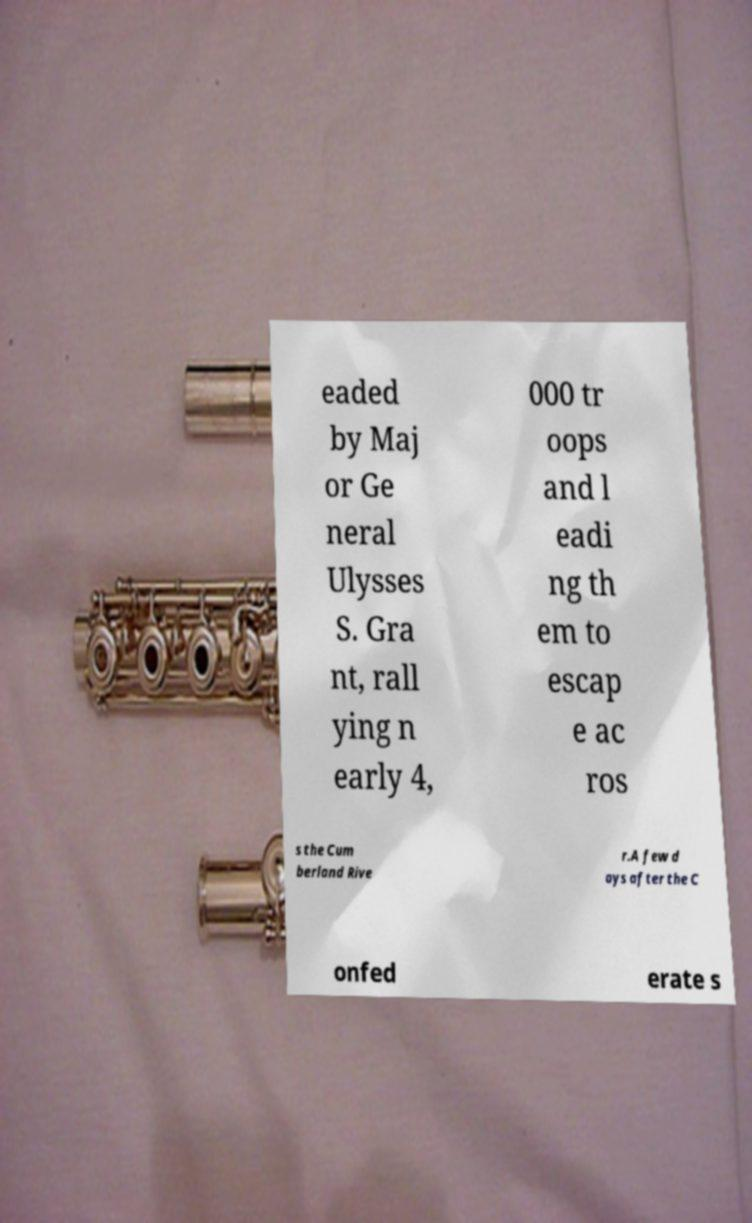There's text embedded in this image that I need extracted. Can you transcribe it verbatim? eaded by Maj or Ge neral Ulysses S. Gra nt, rall ying n early 4, 000 tr oops and l eadi ng th em to escap e ac ros s the Cum berland Rive r.A few d ays after the C onfed erate s 